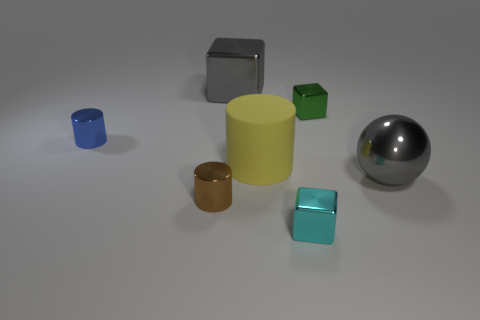Is there any other thing that has the same material as the big yellow cylinder?
Ensure brevity in your answer.  No. What number of other objects are the same material as the yellow cylinder?
Provide a succinct answer. 0. There is a big matte thing; is its color the same as the cylinder that is to the left of the tiny brown cylinder?
Keep it short and to the point. No. There is a big gray thing to the left of the tiny cyan metallic block; what is its material?
Offer a very short reply. Metal. Is there a tiny metallic object that has the same color as the big ball?
Offer a terse response. No. There is a block that is the same size as the gray sphere; what color is it?
Make the answer very short. Gray. What number of big things are green objects or yellow matte cylinders?
Give a very brief answer. 1. Is the number of blue metal things in front of the shiny ball the same as the number of shiny spheres that are right of the small cyan metallic object?
Provide a succinct answer. No. What number of metal cylinders are the same size as the green shiny object?
Keep it short and to the point. 2. How many gray objects are either big objects or tiny rubber blocks?
Your answer should be very brief. 2. 